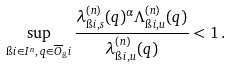Convert formula to latex. <formula><loc_0><loc_0><loc_500><loc_500>\sup _ { \i i \in I ^ { n } , \, q \in \overline { O } _ { \i } i } \frac { \lambda ^ { ( n ) } _ { \i i , s } ( q ) ^ { \alpha } \Lambda ^ { ( n ) } _ { \i i , u } ( q ) } { \lambda ^ { ( n ) } _ { \i i , u } ( q ) } < 1 \, .</formula> 